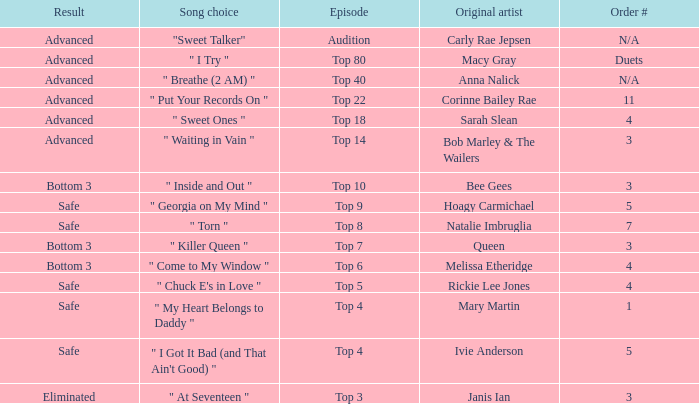Which one of the songs was originally performed by Rickie Lee Jones? " Chuck E's in Love ". 